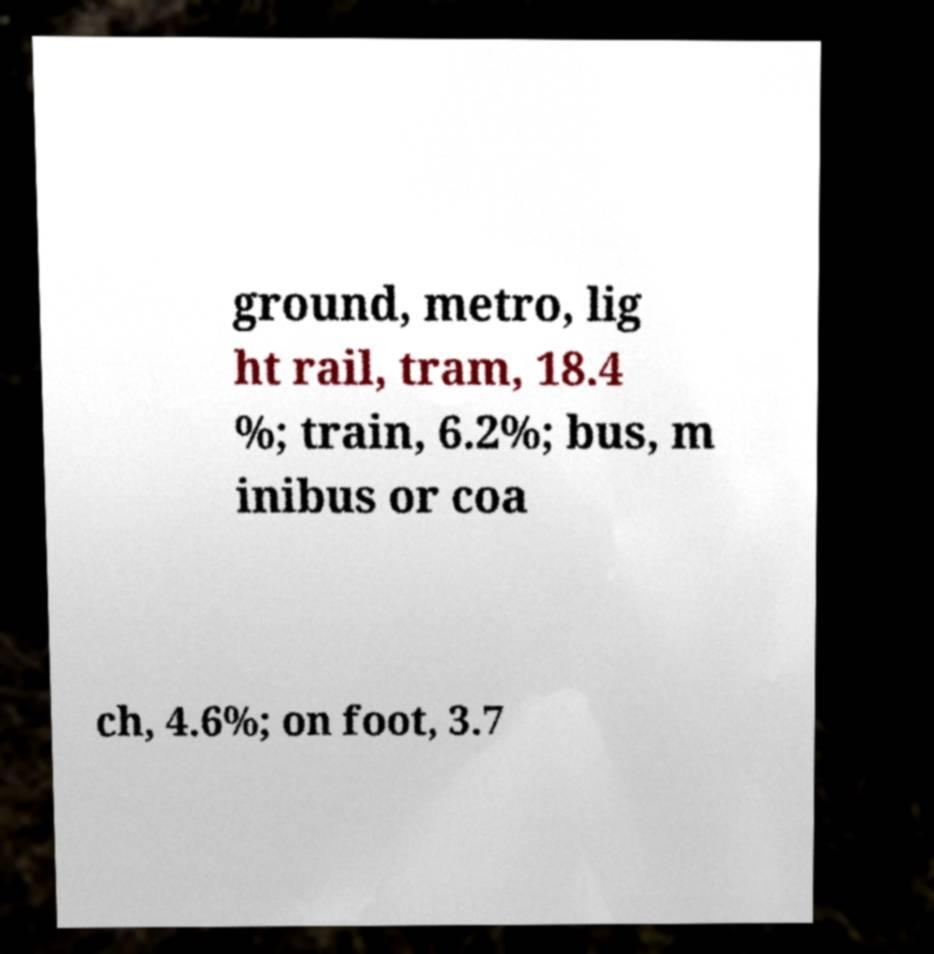For documentation purposes, I need the text within this image transcribed. Could you provide that? ground, metro, lig ht rail, tram, 18.4 %; train, 6.2%; bus, m inibus or coa ch, 4.6%; on foot, 3.7 